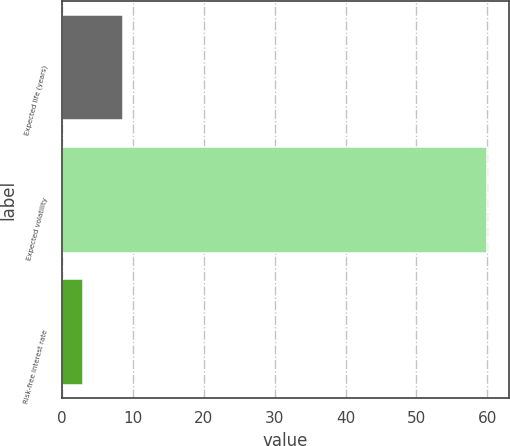Convert chart. <chart><loc_0><loc_0><loc_500><loc_500><bar_chart><fcel>Expected life (years)<fcel>Expected volatility<fcel>Risk-free interest rate<nl><fcel>8.66<fcel>60<fcel>2.95<nl></chart> 